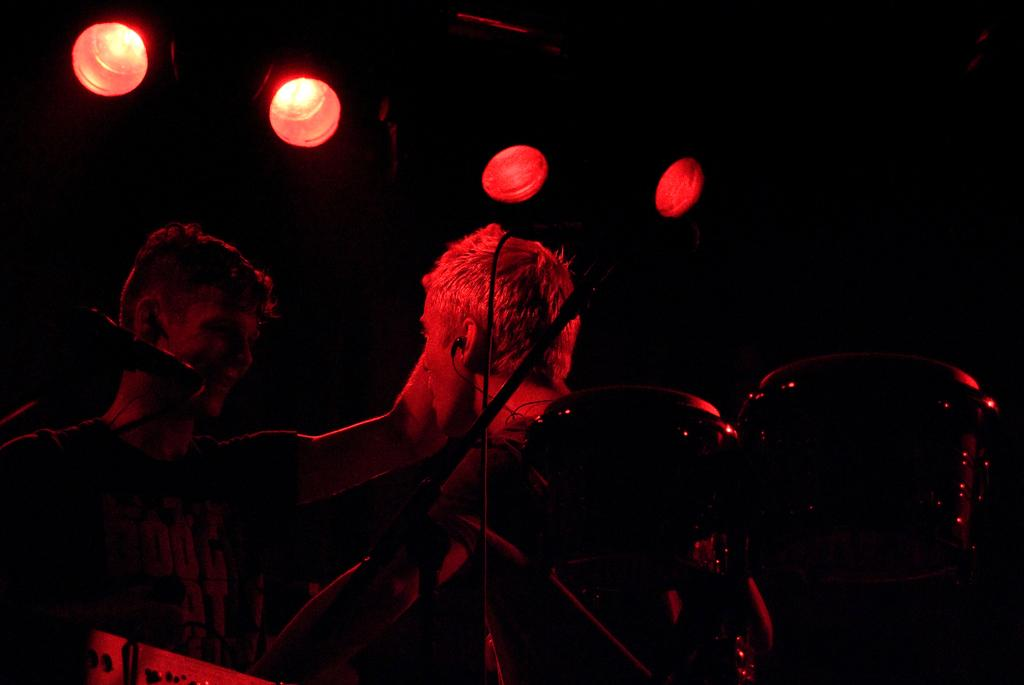What is the person in the image doing? The person is playing a drum and singing into a microphone. What instrument is the person playing? The person is playing a drum. What is the person doing with their voice in the image? The person is singing into a microphone. What can be observed about the lighting in the image? The background of the image is dark, and there are red lights visible on the ceiling. How does the kitten contribute to the musical performance in the image? There is no kitten present in the image, so it cannot contribute to the musical performance. 